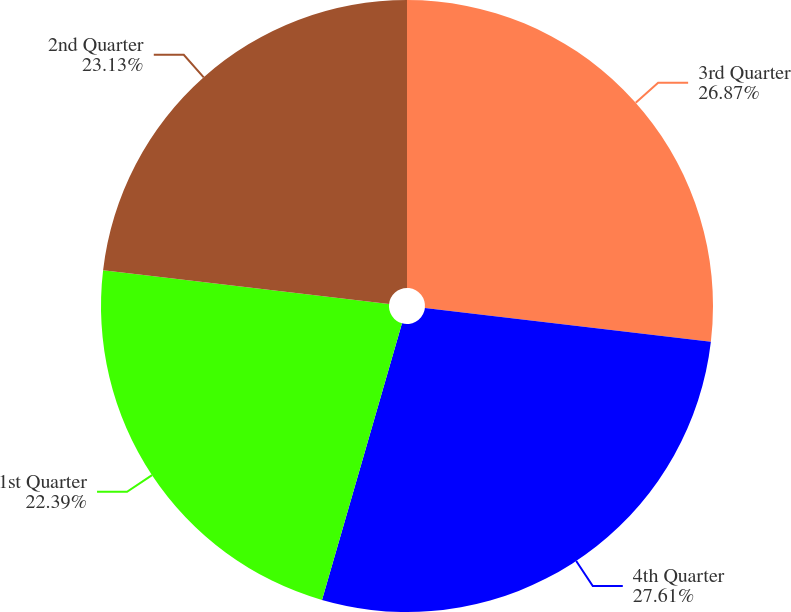Convert chart to OTSL. <chart><loc_0><loc_0><loc_500><loc_500><pie_chart><fcel>3rd Quarter<fcel>4th Quarter<fcel>1st Quarter<fcel>2nd Quarter<nl><fcel>26.87%<fcel>27.61%<fcel>22.39%<fcel>23.13%<nl></chart> 